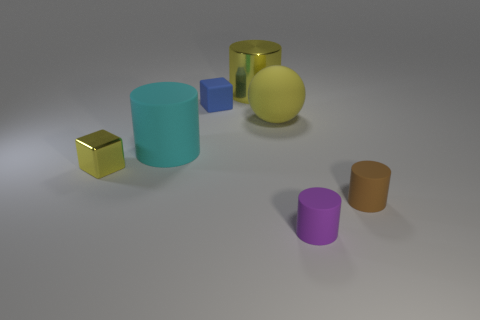There is a yellow matte thing that is on the right side of the shiny thing behind the yellow matte object; what is its shape?
Your answer should be very brief. Sphere. How many purple objects are either matte cylinders or rubber spheres?
Give a very brief answer. 1. What is the color of the large metal cylinder?
Provide a succinct answer. Yellow. Do the purple object and the yellow matte sphere have the same size?
Offer a very short reply. No. Is there any other thing that is the same shape as the large yellow matte thing?
Make the answer very short. No. Are the brown object and the tiny object left of the blue cube made of the same material?
Keep it short and to the point. No. Do the tiny block behind the tiny yellow cube and the big matte cylinder have the same color?
Provide a succinct answer. No. How many small things are on the left side of the purple thing and on the right side of the small yellow metal object?
Provide a short and direct response. 1. What number of other objects are there of the same material as the yellow cube?
Make the answer very short. 1. Are the small cube right of the tiny yellow shiny object and the brown cylinder made of the same material?
Provide a succinct answer. Yes. 